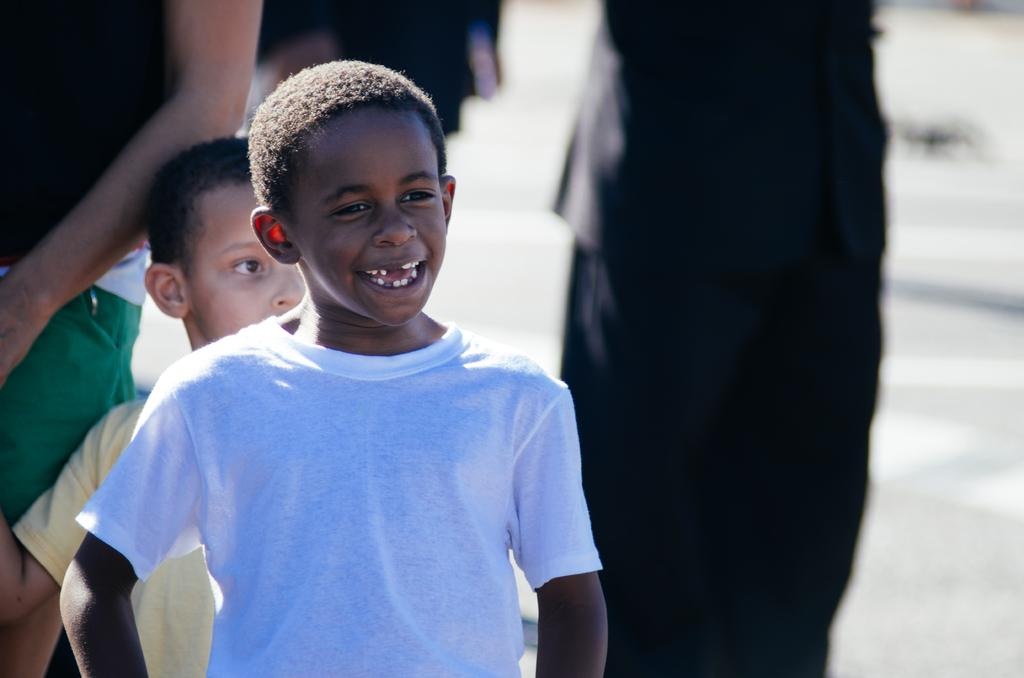What is located on the left side of the image? There is a boy on the left side of the image. What is the boy wearing? The boy is wearing a white t-shirt. What is the boy's facial expression? The boy is smiling. Who is standing behind the boy? There is a person and a child standing at the back of the boy. How would you describe the background of the image? The background of the image is blurred. How many snails can be seen crawling on the boy's white t-shirt in the image? There are no snails visible on the boy's white t-shirt in the image. What type of patch is sewn onto the boy's white t-shirt in the image? There is no patch sewn onto the boy's white t-shirt in the image. 